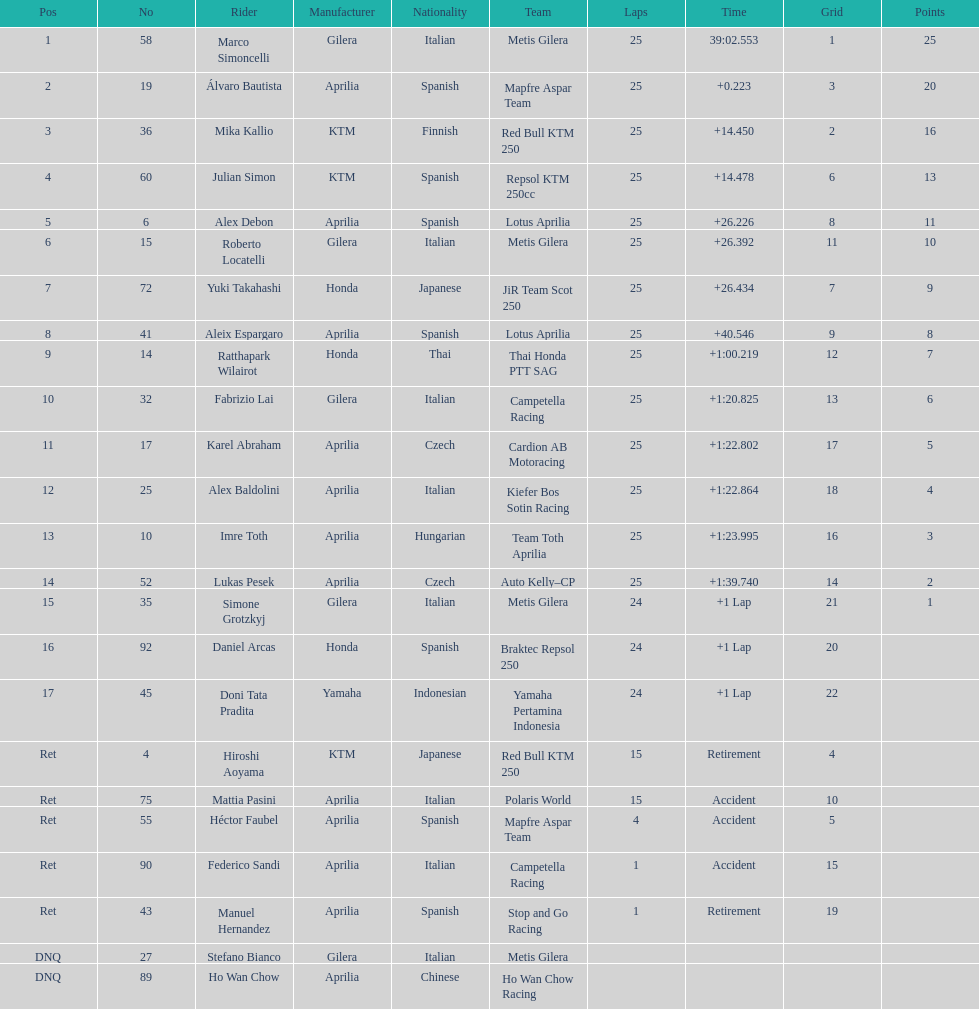How many riders manufacturer is honda? 3. 